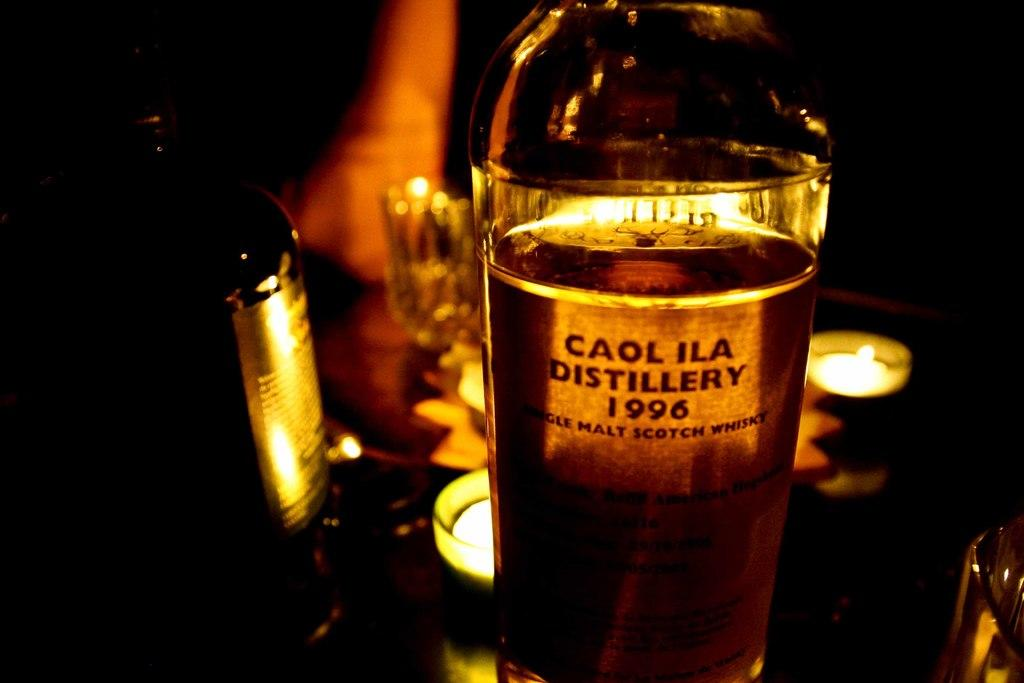<image>
Share a concise interpretation of the image provided. Bottle of Caol ILA Distillery from 1996 inside of a dark area. 